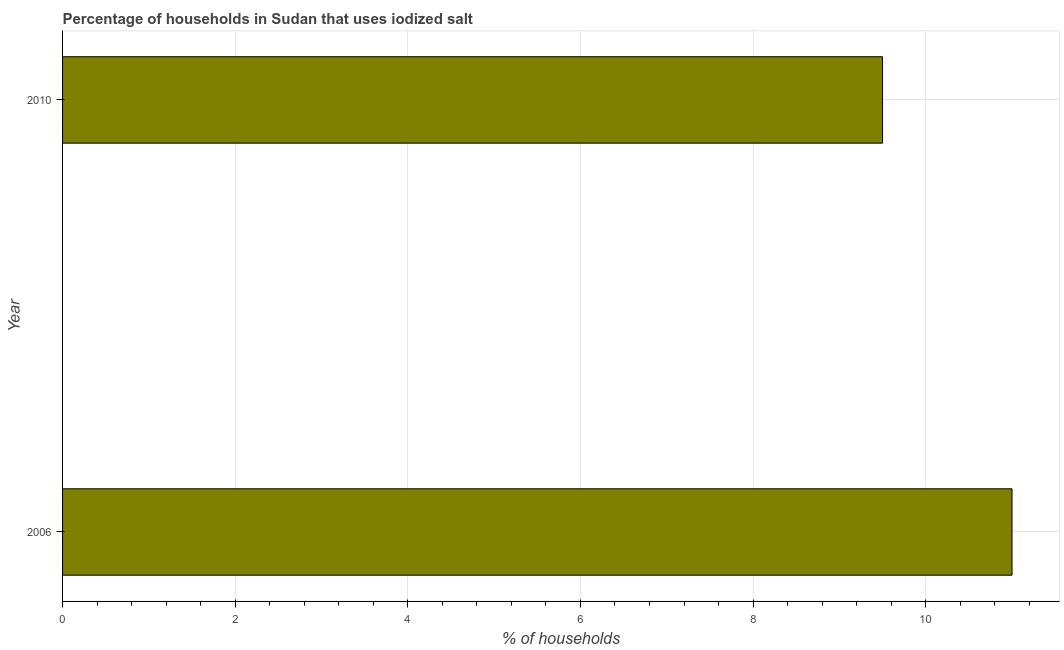Does the graph contain grids?
Your answer should be compact. Yes. What is the title of the graph?
Provide a succinct answer. Percentage of households in Sudan that uses iodized salt. What is the label or title of the X-axis?
Ensure brevity in your answer.  % of households. What is the percentage of households where iodized salt is consumed in 2006?
Ensure brevity in your answer.  11. Across all years, what is the maximum percentage of households where iodized salt is consumed?
Your answer should be very brief. 11. What is the sum of the percentage of households where iodized salt is consumed?
Provide a succinct answer. 20.5. What is the average percentage of households where iodized salt is consumed per year?
Make the answer very short. 10.25. What is the median percentage of households where iodized salt is consumed?
Your answer should be compact. 10.25. What is the ratio of the percentage of households where iodized salt is consumed in 2006 to that in 2010?
Keep it short and to the point. 1.16. Is the percentage of households where iodized salt is consumed in 2006 less than that in 2010?
Give a very brief answer. No. In how many years, is the percentage of households where iodized salt is consumed greater than the average percentage of households where iodized salt is consumed taken over all years?
Make the answer very short. 1. How many bars are there?
Give a very brief answer. 2. How many years are there in the graph?
Ensure brevity in your answer.  2. What is the difference between two consecutive major ticks on the X-axis?
Your response must be concise. 2. What is the difference between the % of households in 2006 and 2010?
Offer a terse response. 1.5. What is the ratio of the % of households in 2006 to that in 2010?
Ensure brevity in your answer.  1.16. 